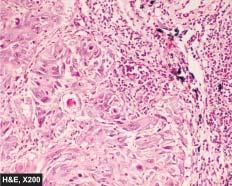what are evident?
Answer the question using a single word or phrase. A few well-developed cell nests with keratinisation 